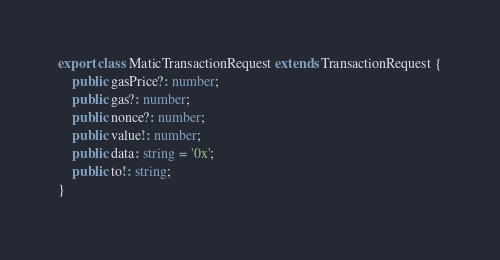<code> <loc_0><loc_0><loc_500><loc_500><_TypeScript_>
export class MaticTransactionRequest extends TransactionRequest {
    public gasPrice?: number;
    public gas?: number;
    public nonce?: number;
    public value!: number;
    public data: string = '0x';
    public to!: string;
}
</code> 